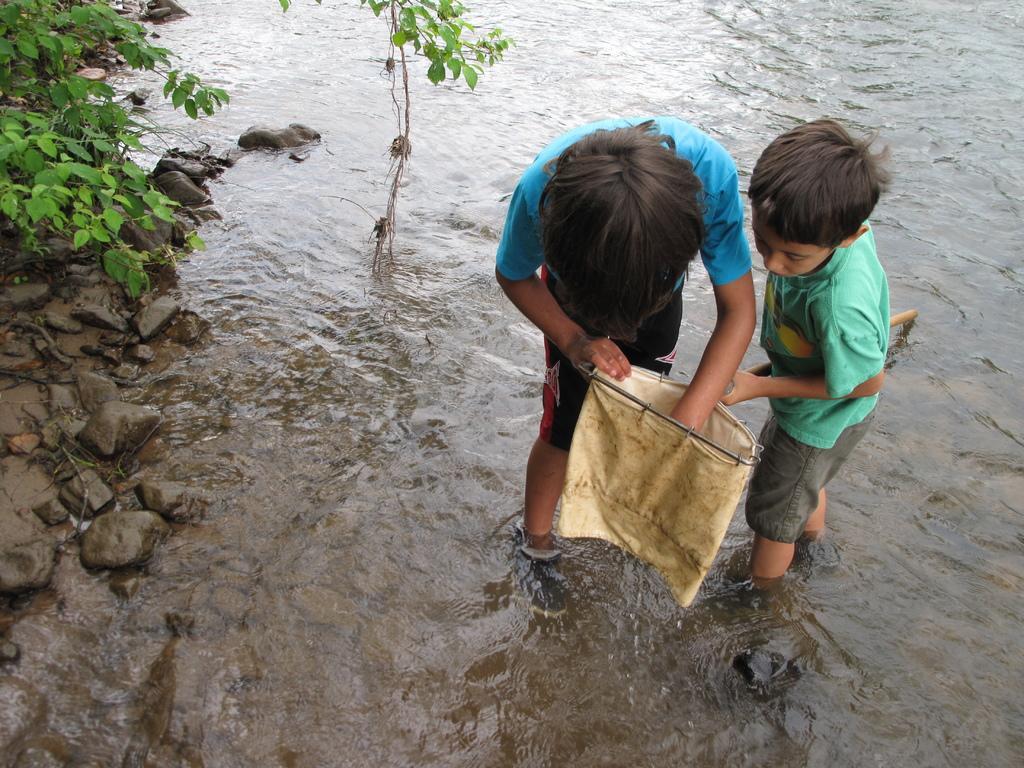Can you describe this image briefly? In this image I can see water and in it I can see few children are standing. I can see both of them are wearing t shirt, shorts and I can see one of them is holding a white colour thing. I can also see few stones and plants. 